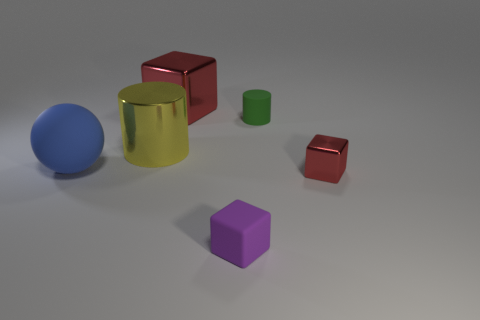The rubber cylinder is what color?
Your answer should be compact. Green. What is the material of the red cube in front of the big block?
Your response must be concise. Metal. What is the size of the other rubber thing that is the same shape as the large yellow thing?
Keep it short and to the point. Small. Are there fewer purple rubber cubes right of the purple block than purple matte cubes?
Provide a succinct answer. Yes. Are there any matte blocks?
Your answer should be very brief. Yes. The small metal thing that is the same shape as the large red thing is what color?
Provide a short and direct response. Red. Does the metal block that is in front of the big red metal thing have the same color as the big shiny cube?
Keep it short and to the point. Yes. Does the rubber cylinder have the same size as the blue matte ball?
Make the answer very short. No. There is a purple thing that is made of the same material as the green object; what shape is it?
Offer a very short reply. Cube. How many other objects are the same shape as the green thing?
Ensure brevity in your answer.  1. 